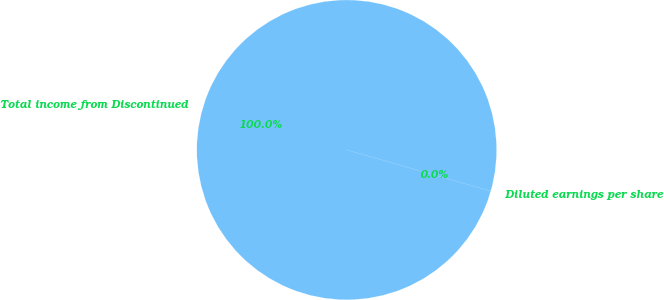<chart> <loc_0><loc_0><loc_500><loc_500><pie_chart><fcel>Total income from Discontinued<fcel>Diluted earnings per share<nl><fcel>100.0%<fcel>0.0%<nl></chart> 